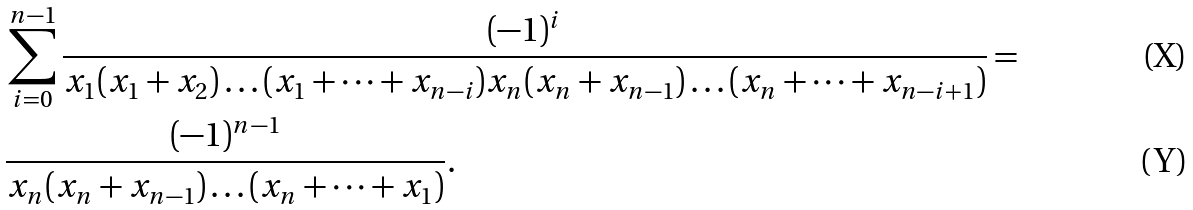Convert formula to latex. <formula><loc_0><loc_0><loc_500><loc_500>& \sum _ { i = 0 } ^ { n - 1 } \frac { ( - 1 ) ^ { i } } { x _ { 1 } ( x _ { 1 } + x _ { 2 } ) \dots ( x _ { 1 } + \dots + x _ { n - i } ) x _ { n } ( x _ { n } + x _ { n - 1 } ) \dots ( x _ { n } + \dots + x _ { n - i + 1 } ) } = \\ & \frac { ( - 1 ) ^ { n - 1 } } { x _ { n } ( x _ { n } + x _ { n - 1 } ) \dots ( x _ { n } + \dots + x _ { 1 } ) } .</formula> 